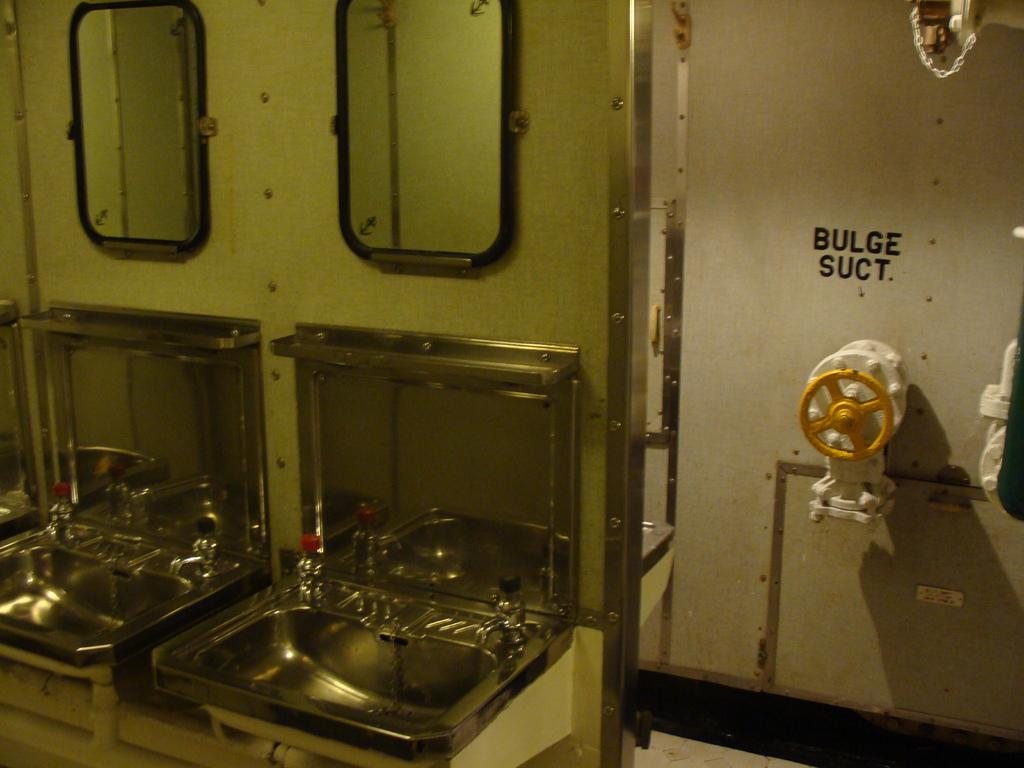Provide a one-sentence caption for the provided image. A room with 2 sinks and a wall showing Bulge suct at the back. 